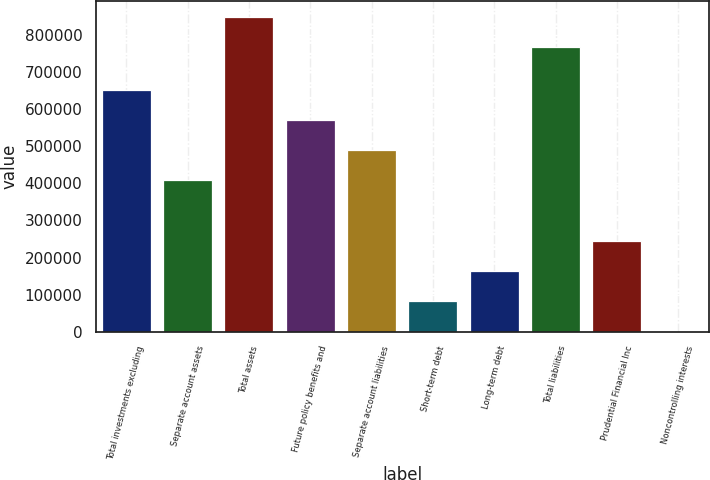<chart> <loc_0><loc_0><loc_500><loc_500><bar_chart><fcel>Total investments excluding<fcel>Separate account assets<fcel>Total assets<fcel>Future policy benefits and<fcel>Separate account liabilities<fcel>Short-term debt<fcel>Long-term debt<fcel>Total liabilities<fcel>Prudential Financial Inc<fcel>Noncontrolling interests<nl><fcel>652145<fcel>407746<fcel>847513<fcel>570679<fcel>489212<fcel>81880.4<fcel>163347<fcel>766047<fcel>244813<fcel>414<nl></chart> 